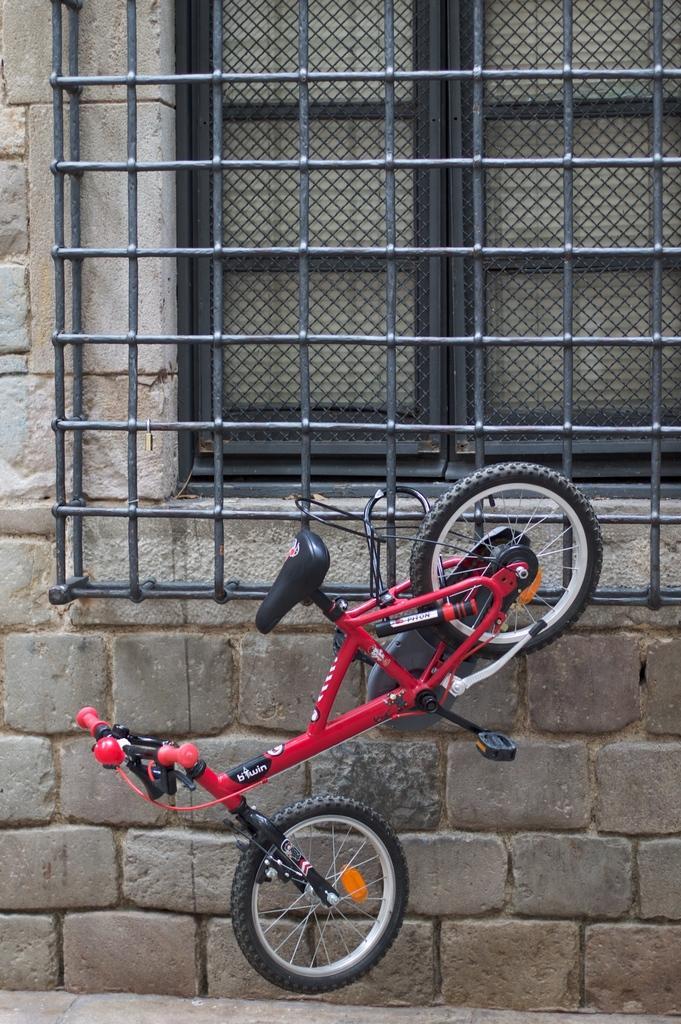Can you describe this image briefly? There is a red color bicycle tied to an iron fence which is attached to the brick wall of a building. Which is having a window. Beside this building, there is a footpath. 